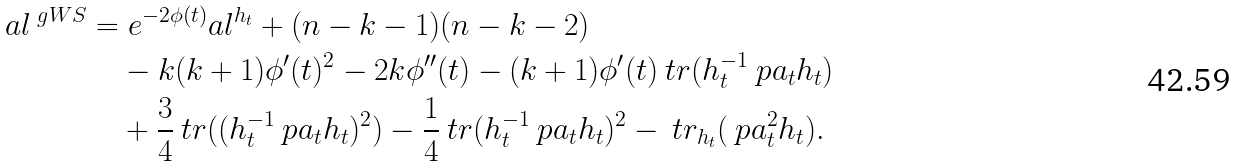Convert formula to latex. <formula><loc_0><loc_0><loc_500><loc_500>a l ^ { \ g W S } & = e ^ { - 2 \phi ( t ) } a l ^ { h _ { t } } + ( n - k - 1 ) ( n - k - 2 ) \\ & \quad - k ( k + 1 ) \phi ^ { \prime } ( t ) ^ { 2 } - 2 k \phi ^ { \prime \prime } ( t ) - ( k + 1 ) \phi ^ { \prime } ( t ) \ t r ( h _ { t } ^ { - 1 } \ p a _ { t } h _ { t } ) \\ & \quad + \frac { 3 } { 4 } \ t r ( ( h _ { t } ^ { - 1 } \ p a _ { t } h _ { t } ) ^ { 2 } ) - \frac { 1 } { 4 } \ t r ( h _ { t } ^ { - 1 } \ p a _ { t } h _ { t } ) ^ { 2 } - \ t r _ { h _ { t } } ( \ p a _ { t } ^ { 2 } h _ { t } ) .</formula> 